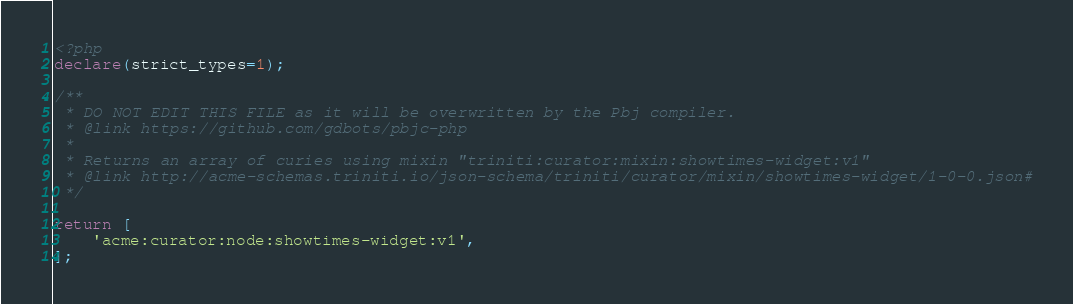Convert code to text. <code><loc_0><loc_0><loc_500><loc_500><_PHP_><?php
declare(strict_types=1);

/**
 * DO NOT EDIT THIS FILE as it will be overwritten by the Pbj compiler.
 * @link https://github.com/gdbots/pbjc-php
 *
 * Returns an array of curies using mixin "triniti:curator:mixin:showtimes-widget:v1"
 * @link http://acme-schemas.triniti.io/json-schema/triniti/curator/mixin/showtimes-widget/1-0-0.json#
 */

return [
    'acme:curator:node:showtimes-widget:v1',
];
</code> 